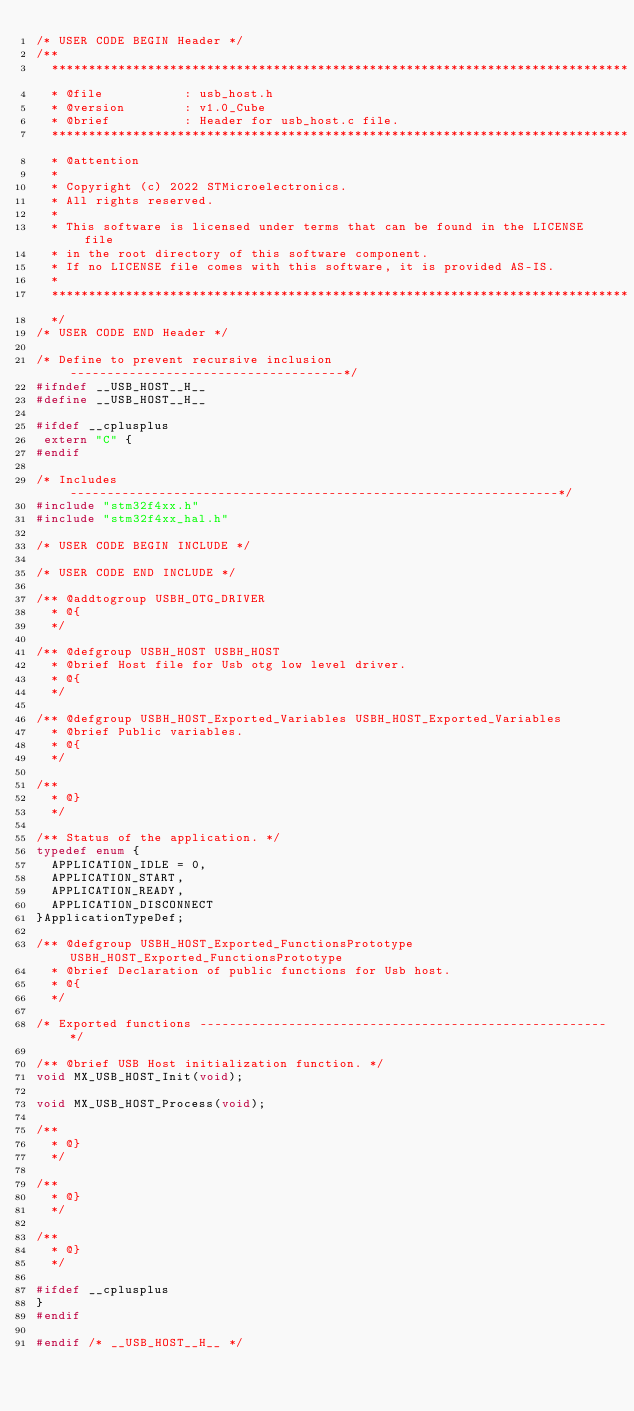<code> <loc_0><loc_0><loc_500><loc_500><_C_>/* USER CODE BEGIN Header */
/**
  ******************************************************************************
  * @file           : usb_host.h
  * @version        : v1.0_Cube
  * @brief          : Header for usb_host.c file.
  ******************************************************************************
  * @attention
  *
  * Copyright (c) 2022 STMicroelectronics.
  * All rights reserved.
  *
  * This software is licensed under terms that can be found in the LICENSE file
  * in the root directory of this software component.
  * If no LICENSE file comes with this software, it is provided AS-IS.
  *
  ******************************************************************************
  */
/* USER CODE END Header */

/* Define to prevent recursive inclusion -------------------------------------*/
#ifndef __USB_HOST__H__
#define __USB_HOST__H__

#ifdef __cplusplus
 extern "C" {
#endif

/* Includes ------------------------------------------------------------------*/
#include "stm32f4xx.h"
#include "stm32f4xx_hal.h"

/* USER CODE BEGIN INCLUDE */

/* USER CODE END INCLUDE */

/** @addtogroup USBH_OTG_DRIVER
  * @{
  */

/** @defgroup USBH_HOST USBH_HOST
  * @brief Host file for Usb otg low level driver.
  * @{
  */

/** @defgroup USBH_HOST_Exported_Variables USBH_HOST_Exported_Variables
  * @brief Public variables.
  * @{
  */

/**
  * @}
  */

/** Status of the application. */
typedef enum {
  APPLICATION_IDLE = 0,
  APPLICATION_START,
  APPLICATION_READY,
  APPLICATION_DISCONNECT
}ApplicationTypeDef;

/** @defgroup USBH_HOST_Exported_FunctionsPrototype USBH_HOST_Exported_FunctionsPrototype
  * @brief Declaration of public functions for Usb host.
  * @{
  */

/* Exported functions -------------------------------------------------------*/

/** @brief USB Host initialization function. */
void MX_USB_HOST_Init(void);

void MX_USB_HOST_Process(void);

/**
  * @}
  */

/**
  * @}
  */

/**
  * @}
  */

#ifdef __cplusplus
}
#endif

#endif /* __USB_HOST__H__ */

</code> 